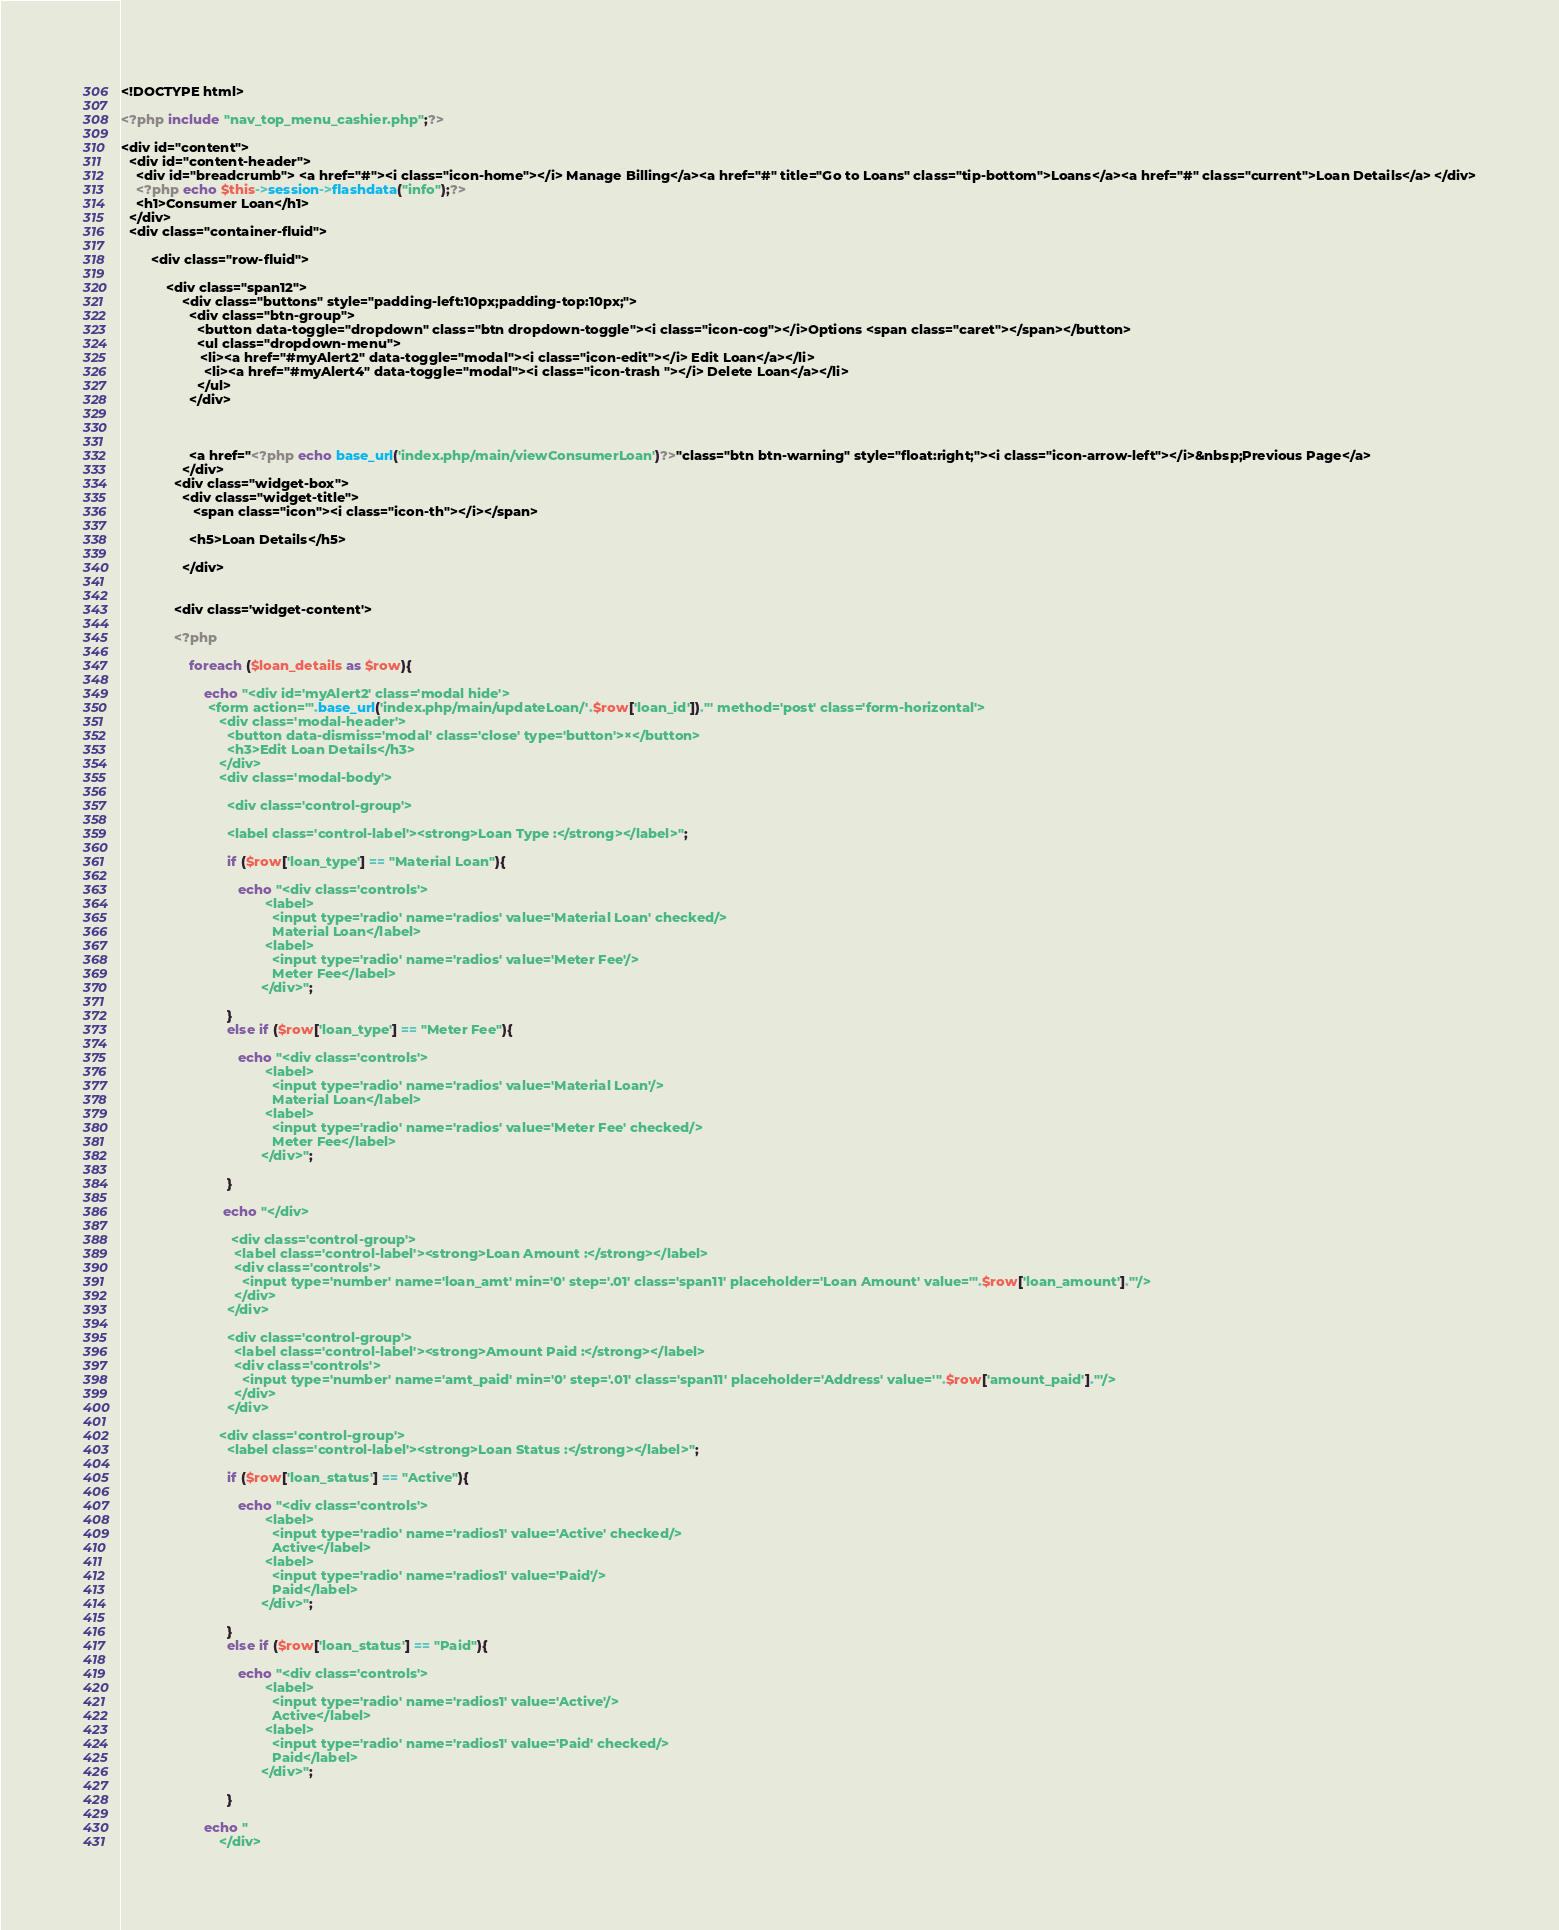<code> <loc_0><loc_0><loc_500><loc_500><_PHP_><!DOCTYPE html>

<?php include "nav_top_menu_cashier.php";?>

<div id="content">
  <div id="content-header">
    <div id="breadcrumb"> <a href="#"><i class="icon-home"></i> Manage Billing</a><a href="#" title="Go to Loans" class="tip-bottom">Loans</a><a href="#" class="current">Loan Details</a> </div>
    <?php echo $this->session->flashdata("info");?>
    <h1>Consumer Loan</h1>
  </div>
  <div class="container-fluid">
  
        <div class="row-fluid">
        
            <div class="span12">
                <div class="buttons" style="padding-left:10px;padding-top:10px;">
                  <div class="btn-group">
                    <button data-toggle="dropdown" class="btn dropdown-toggle"><i class="icon-cog"></i>Options <span class="caret"></span></button>
                    <ul class="dropdown-menu">
                     <li><a href="#myAlert2" data-toggle="modal"><i class="icon-edit"></i> Edit Loan</a></li>
                      <li><a href="#myAlert4" data-toggle="modal"><i class="icon-trash "></i> Delete Loan</a></li>
                    </ul>
                  </div>
                 
                 
                 
                  <a href="<?php echo base_url('index.php/main/viewConsumerLoan')?>"class="btn btn-warning" style="float:right;"><i class="icon-arrow-left"></i>&nbsp;Previous Page</a>
                </div>
              <div class="widget-box">
                <div class="widget-title">
                   <span class="icon"><i class="icon-th"></i></span> 
                
                  <h5>Loan Details</h5>

                </div>
                
                 
              <div class='widget-content'>  

              <?php

                  foreach ($loan_details as $row){

                      echo "<div id='myAlert2' class='modal hide'>
                       <form action='".base_url('index.php/main/updateLoan/'.$row['loan_id'])."' method='post' class='form-horizontal'>
                          <div class='modal-header'>
                            <button data-dismiss='modal' class='close' type='button'>×</button>
                            <h3>Edit Loan Details</h3>
                          </div>
                          <div class='modal-body'>
                           
                            <div class='control-group'>

                            <label class='control-label'><strong>Loan Type :</strong></label>";

                            if ($row['loan_type'] == "Material Loan"){

                               echo "<div class='controls'>
                                      <label>
                                        <input type='radio' name='radios' value='Material Loan' checked/>
                                        Material Loan</label>
                                      <label>
                                        <input type='radio' name='radios' value='Meter Fee'/>
                                        Meter Fee</label>
                                     </div>";

                            }
                            else if ($row['loan_type'] == "Meter Fee"){

                               echo "<div class='controls'>
                                      <label>
                                        <input type='radio' name='radios' value='Material Loan'/>
                                        Material Loan</label>
                                      <label>
                                        <input type='radio' name='radios' value='Meter Fee' checked/>
                                        Meter Fee</label>
                                     </div>";

                            }

                           echo "</div>

                             <div class='control-group'>
                              <label class='control-label'><strong>Loan Amount :</strong></label>
                              <div class='controls'>
                                <input type='number' name='loan_amt' min='0' step='.01' class='span11' placeholder='Loan Amount' value='".$row['loan_amount']."'/>
                              </div>
                            </div>

                            <div class='control-group'>
                              <label class='control-label'><strong>Amount Paid :</strong></label>
                              <div class='controls'>
                                <input type='number' name='amt_paid' min='0' step='.01' class='span11' placeholder='Address' value='".$row['amount_paid']."'/>
                              </div>
                            </div>

                          <div class='control-group'>
                            <label class='control-label'><strong>Loan Status :</strong></label>";

                            if ($row['loan_status'] == "Active"){

                               echo "<div class='controls'>
                                      <label>
                                        <input type='radio' name='radios1' value='Active' checked/>
                                        Active</label>
                                      <label>
                                        <input type='radio' name='radios1' value='Paid'/>
                                        Paid</label>
                                     </div>";

                            }
                            else if ($row['loan_status'] == "Paid"){

                               echo "<div class='controls'>
                                      <label>
                                        <input type='radio' name='radios1' value='Active'/>
                                        Active</label>
                                      <label>
                                        <input type='radio' name='radios1' value='Paid' checked/>
                                        Paid</label>
                                     </div>";

                            }

                      echo "
                          </div></code> 